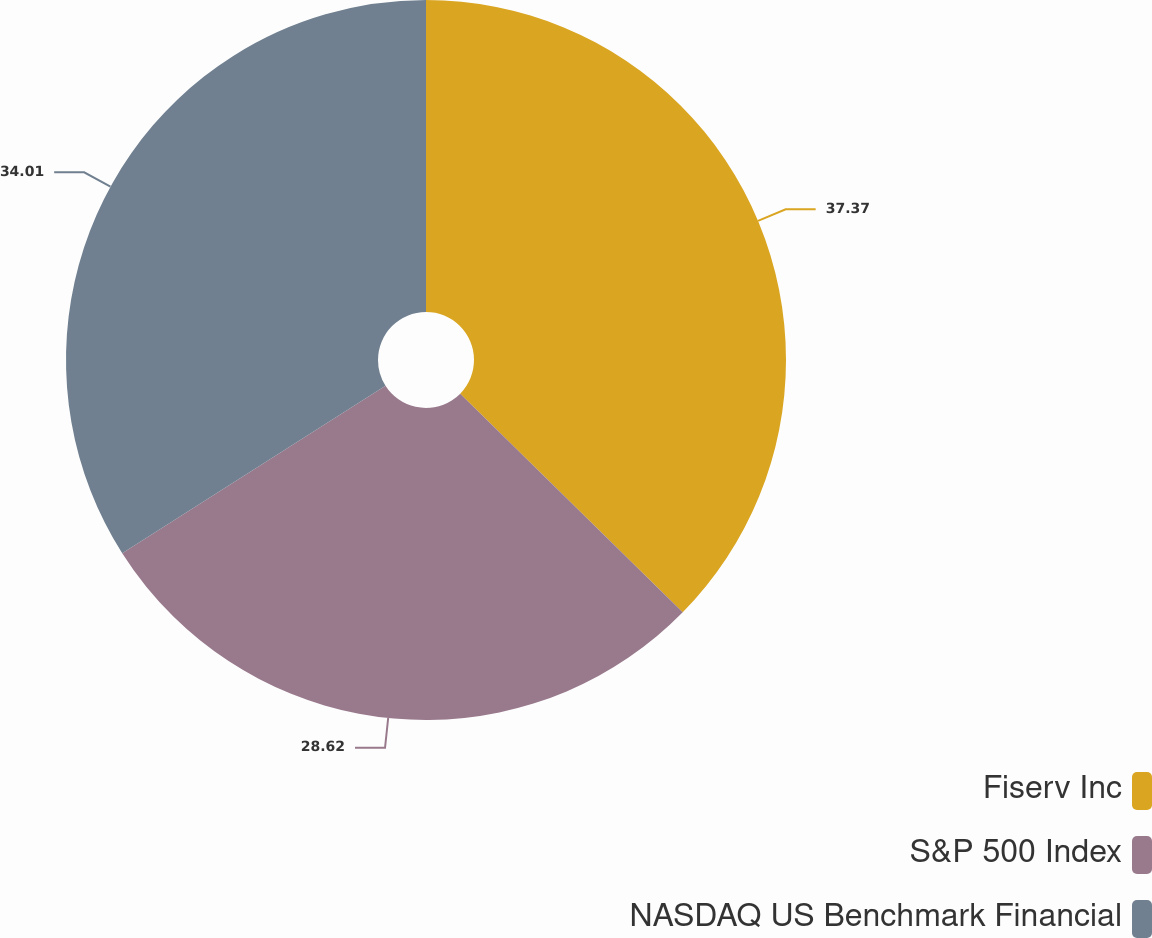Convert chart to OTSL. <chart><loc_0><loc_0><loc_500><loc_500><pie_chart><fcel>Fiserv Inc<fcel>S&P 500 Index<fcel>NASDAQ US Benchmark Financial<nl><fcel>37.36%<fcel>28.62%<fcel>34.01%<nl></chart> 